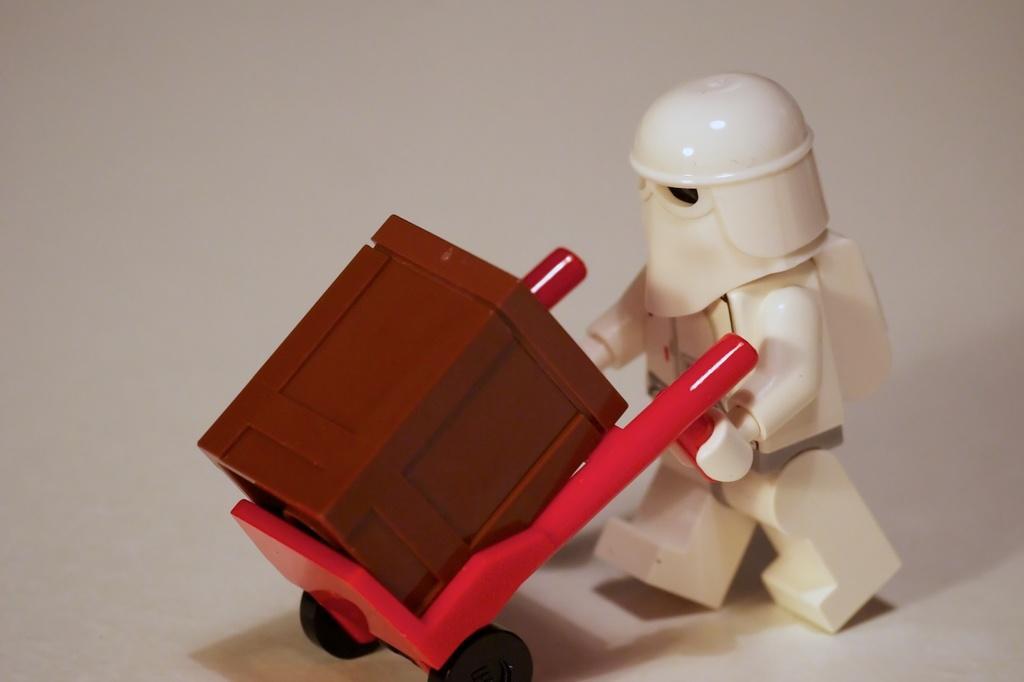How would you summarize this image in a sentence or two? In this image, we can see a white color toy and there is a red color trolley with black color wheels, there is a brown color box, there is a white color background. 